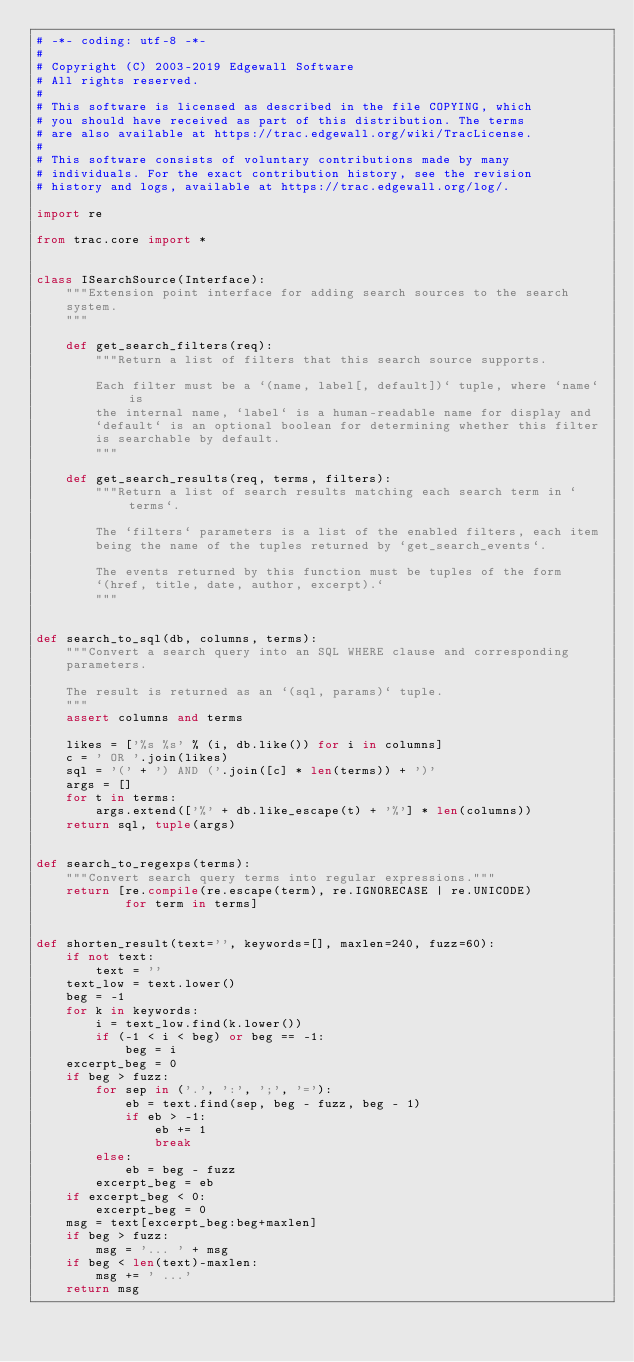Convert code to text. <code><loc_0><loc_0><loc_500><loc_500><_Python_># -*- coding: utf-8 -*-
#
# Copyright (C) 2003-2019 Edgewall Software
# All rights reserved.
#
# This software is licensed as described in the file COPYING, which
# you should have received as part of this distribution. The terms
# are also available at https://trac.edgewall.org/wiki/TracLicense.
#
# This software consists of voluntary contributions made by many
# individuals. For the exact contribution history, see the revision
# history and logs, available at https://trac.edgewall.org/log/.

import re

from trac.core import *


class ISearchSource(Interface):
    """Extension point interface for adding search sources to the search
    system.
    """

    def get_search_filters(req):
        """Return a list of filters that this search source supports.

        Each filter must be a `(name, label[, default])` tuple, where `name` is
        the internal name, `label` is a human-readable name for display and
        `default` is an optional boolean for determining whether this filter
        is searchable by default.
        """

    def get_search_results(req, terms, filters):
        """Return a list of search results matching each search term in `terms`.

        The `filters` parameters is a list of the enabled filters, each item
        being the name of the tuples returned by `get_search_events`.

        The events returned by this function must be tuples of the form
        `(href, title, date, author, excerpt).`
        """


def search_to_sql(db, columns, terms):
    """Convert a search query into an SQL WHERE clause and corresponding
    parameters.

    The result is returned as an `(sql, params)` tuple.
    """
    assert columns and terms

    likes = ['%s %s' % (i, db.like()) for i in columns]
    c = ' OR '.join(likes)
    sql = '(' + ') AND ('.join([c] * len(terms)) + ')'
    args = []
    for t in terms:
        args.extend(['%' + db.like_escape(t) + '%'] * len(columns))
    return sql, tuple(args)


def search_to_regexps(terms):
    """Convert search query terms into regular expressions."""
    return [re.compile(re.escape(term), re.IGNORECASE | re.UNICODE)
            for term in terms]


def shorten_result(text='', keywords=[], maxlen=240, fuzz=60):
    if not text:
        text = ''
    text_low = text.lower()
    beg = -1
    for k in keywords:
        i = text_low.find(k.lower())
        if (-1 < i < beg) or beg == -1:
            beg = i
    excerpt_beg = 0
    if beg > fuzz:
        for sep in ('.', ':', ';', '='):
            eb = text.find(sep, beg - fuzz, beg - 1)
            if eb > -1:
                eb += 1
                break
        else:
            eb = beg - fuzz
        excerpt_beg = eb
    if excerpt_beg < 0:
        excerpt_beg = 0
    msg = text[excerpt_beg:beg+maxlen]
    if beg > fuzz:
        msg = '... ' + msg
    if beg < len(text)-maxlen:
        msg += ' ...'
    return msg
</code> 